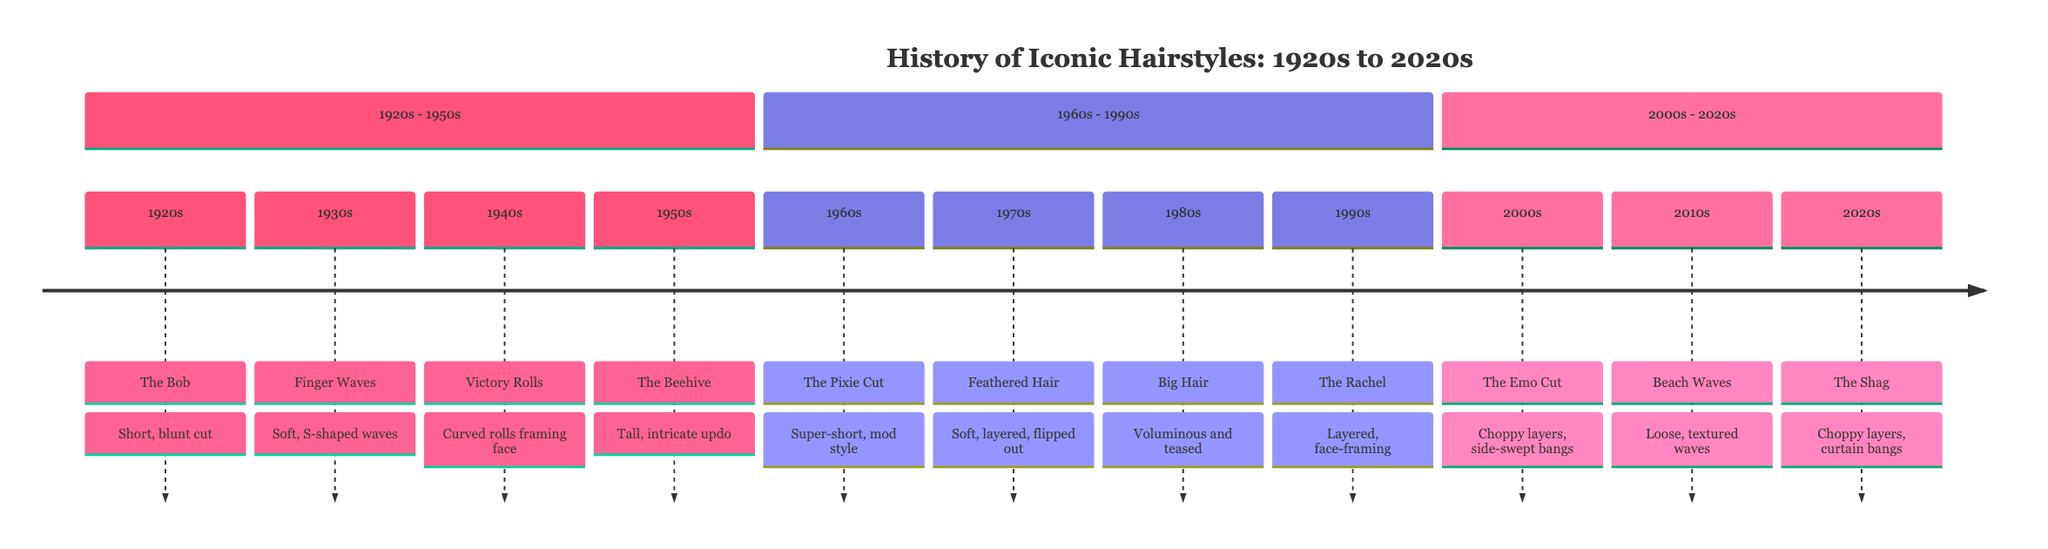What iconic hairstyle represented the 1920s? The diagram indicates that the iconic hairstyle for the 1920s is “The Bob,” which is a short, blunt haircut associated with the flapper movement.
Answer: The Bob What decade features the hairstyle known as "Big Hair"? From the timeline, "Big Hair" is listed under the 1980s, indicating that this hairstyle was popular during that decade.
Answer: 1980s Which hairstyle is known for soft, S-shaped waves? According to the timeline, "Finger Waves" are recognized for their soft, S-shaped pattern and were popular in the 1930s.
Answer: Finger Waves In what decade did "The Shag" become iconic? The timeline shows that "The Shag" hairstyle gained prominence in the 2020s, which is depicted in the last section of the timeline.
Answer: 2020s How many iconic hairstyles are classified in the timeline? By counting the hairstyles listed across the timeline sections, there are a total of 11 iconic hairstyles mentioned from the 1920s to the 2020s.
Answer: 11 What is the common feature of hairstyles from the 2010s? The 2010s hairstyles in the diagram show a trend toward loose and textured hair, specifically highlighted by "Beach Waves."
Answer: Loose, textured waves Which hairstyle became popular due to the character Rachel on "Friends"? Reviewing the timeline, "The Rachel" is the hairstyle that was named after Jennifer Aniston's character on the show "Friends."
Answer: The Rachel What decade does the "Victory Rolls" hairstyle belong to? The diagram indicates that "Victory Rolls" were popular in the 1940s, aligning with the inspirational context of World War II.
Answer: 1940s What hairstyle from the 1970s was made famous by Farrah Fawcett? The timeline specifically identifies "Feathered Hair" as the hairstyle popularized by Farrah Fawcett in the 1970s.
Answer: Feathered Hair 